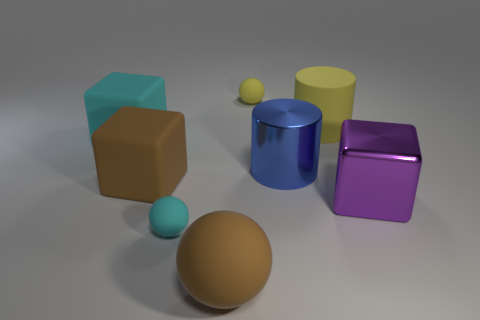What number of blue metallic cylinders are the same size as the purple shiny block?
Provide a short and direct response. 1. How many rubber objects are in front of the large cyan object and to the right of the brown rubber cube?
Make the answer very short. 2. Is the size of the sphere that is behind the cyan matte cube the same as the matte cylinder?
Keep it short and to the point. No. Is there a matte thing that has the same color as the large shiny cube?
Keep it short and to the point. No. There is a purple cube that is the same material as the blue cylinder; what size is it?
Ensure brevity in your answer.  Large. Is the number of rubber objects that are in front of the big purple cube greater than the number of big cyan blocks that are behind the big yellow rubber cylinder?
Your answer should be very brief. Yes. How many other things are made of the same material as the purple thing?
Your answer should be very brief. 1. Is the material of the cube to the right of the brown matte sphere the same as the brown sphere?
Ensure brevity in your answer.  No. What is the shape of the large blue thing?
Your response must be concise. Cylinder. Is the number of yellow matte spheres in front of the big sphere greater than the number of large blue objects?
Give a very brief answer. No. 